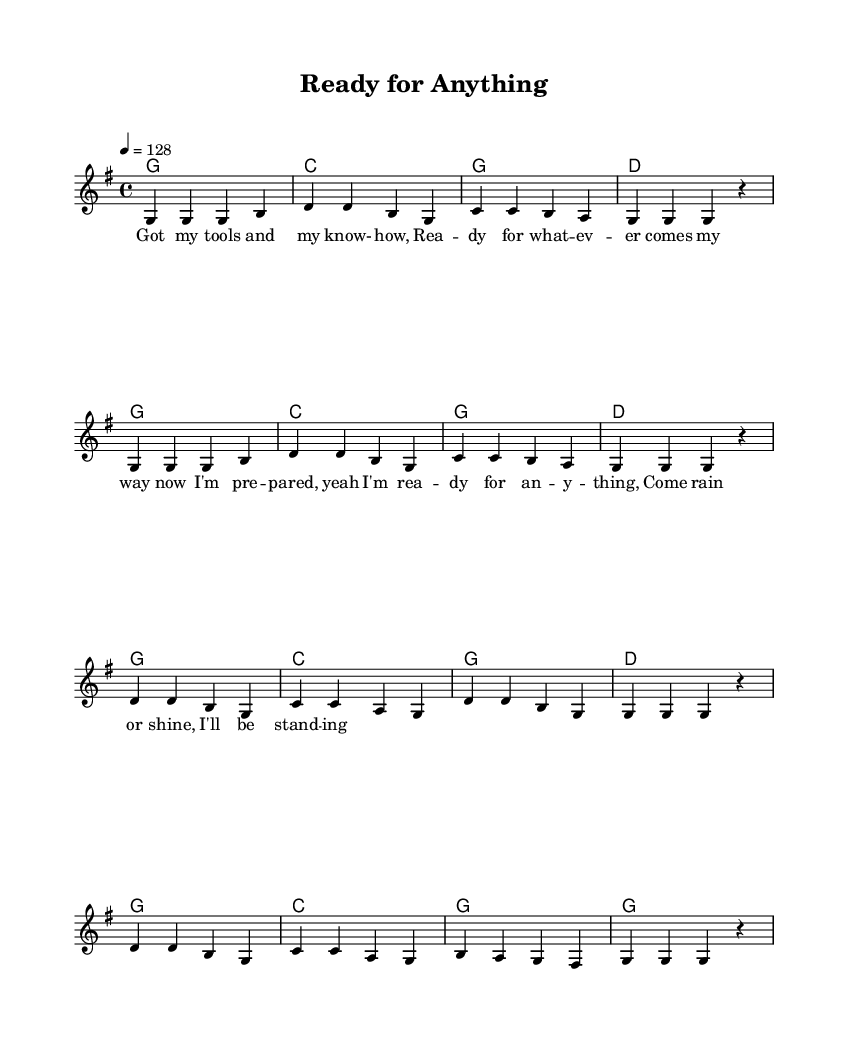What is the key signature of this music? The key signature indicates the notes used in the piece. In this case, it is G major, which has one sharp (F#).
Answer: G major What is the time signature? The time signature is found at the beginning of the music indicating how many beats are in each measure. Here, it is 4/4, meaning there are four beats per measure.
Answer: 4/4 What is the tempo marking? The tempo marking is the speed of the music indicated at the start. It shows that the piece should be played at a rate of 128 beats per minute.
Answer: 128 How many measures are in the verse? By counting the music notation for the verse section, we can see there are 8 measures in total.
Answer: 8 What is the first word sung in the chorus? The lyrics of the chorus reveal the first word, which is "I'm." This is found at the start of the chorus section.
Answer: I'm Why is the structure of the song significant to its country genre? The song features a repetitive structure typical of country music, with verses followed by a memorable chorus. This reflects themes of self-reliance and preparedness, common in country tunes.
Answer: Repetitive structure 